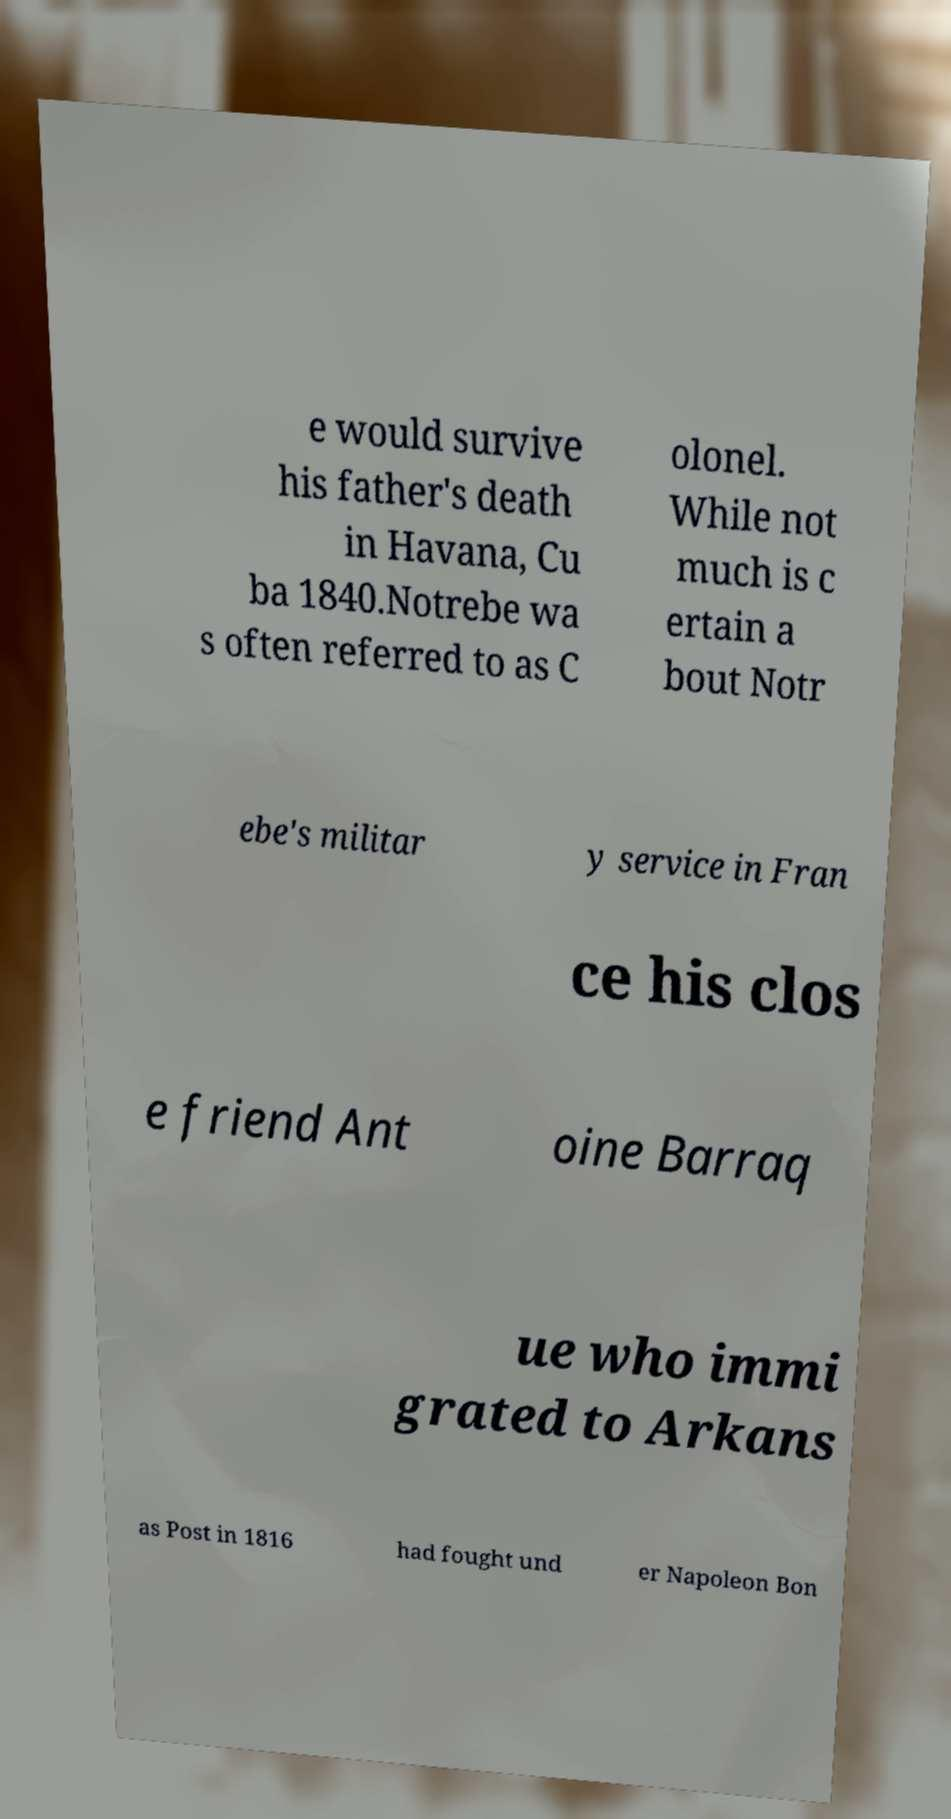Could you extract and type out the text from this image? e would survive his father's death in Havana, Cu ba 1840.Notrebe wa s often referred to as C olonel. While not much is c ertain a bout Notr ebe's militar y service in Fran ce his clos e friend Ant oine Barraq ue who immi grated to Arkans as Post in 1816 had fought und er Napoleon Bon 